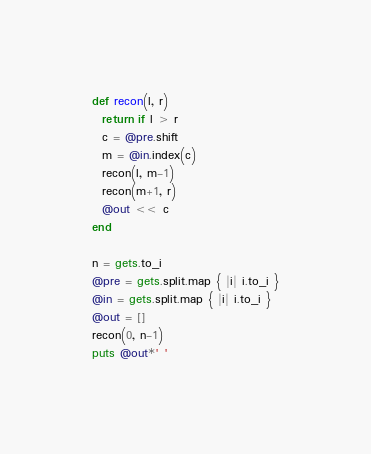Convert code to text. <code><loc_0><loc_0><loc_500><loc_500><_Ruby_>def recon(l, r)
  return if l > r
  c = @pre.shift
  m = @in.index(c)
  recon(l, m-1)
  recon(m+1, r)
  @out << c
end

n = gets.to_i
@pre = gets.split.map { |i| i.to_i }
@in = gets.split.map { |i| i.to_i }
@out = []
recon(0, n-1)
puts @out*' '</code> 